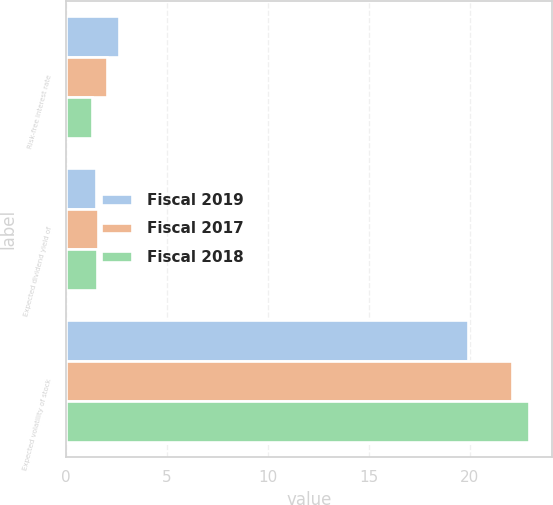Convert chart to OTSL. <chart><loc_0><loc_0><loc_500><loc_500><stacked_bar_chart><ecel><fcel>Risk-free interest rate<fcel>Expected dividend yield of<fcel>Expected volatility of stock<nl><fcel>Fiscal 2019<fcel>2.64<fcel>1.47<fcel>19.91<nl><fcel>Fiscal 2017<fcel>2.01<fcel>1.58<fcel>22.08<nl><fcel>Fiscal 2018<fcel>1.29<fcel>1.54<fcel>22.92<nl></chart> 